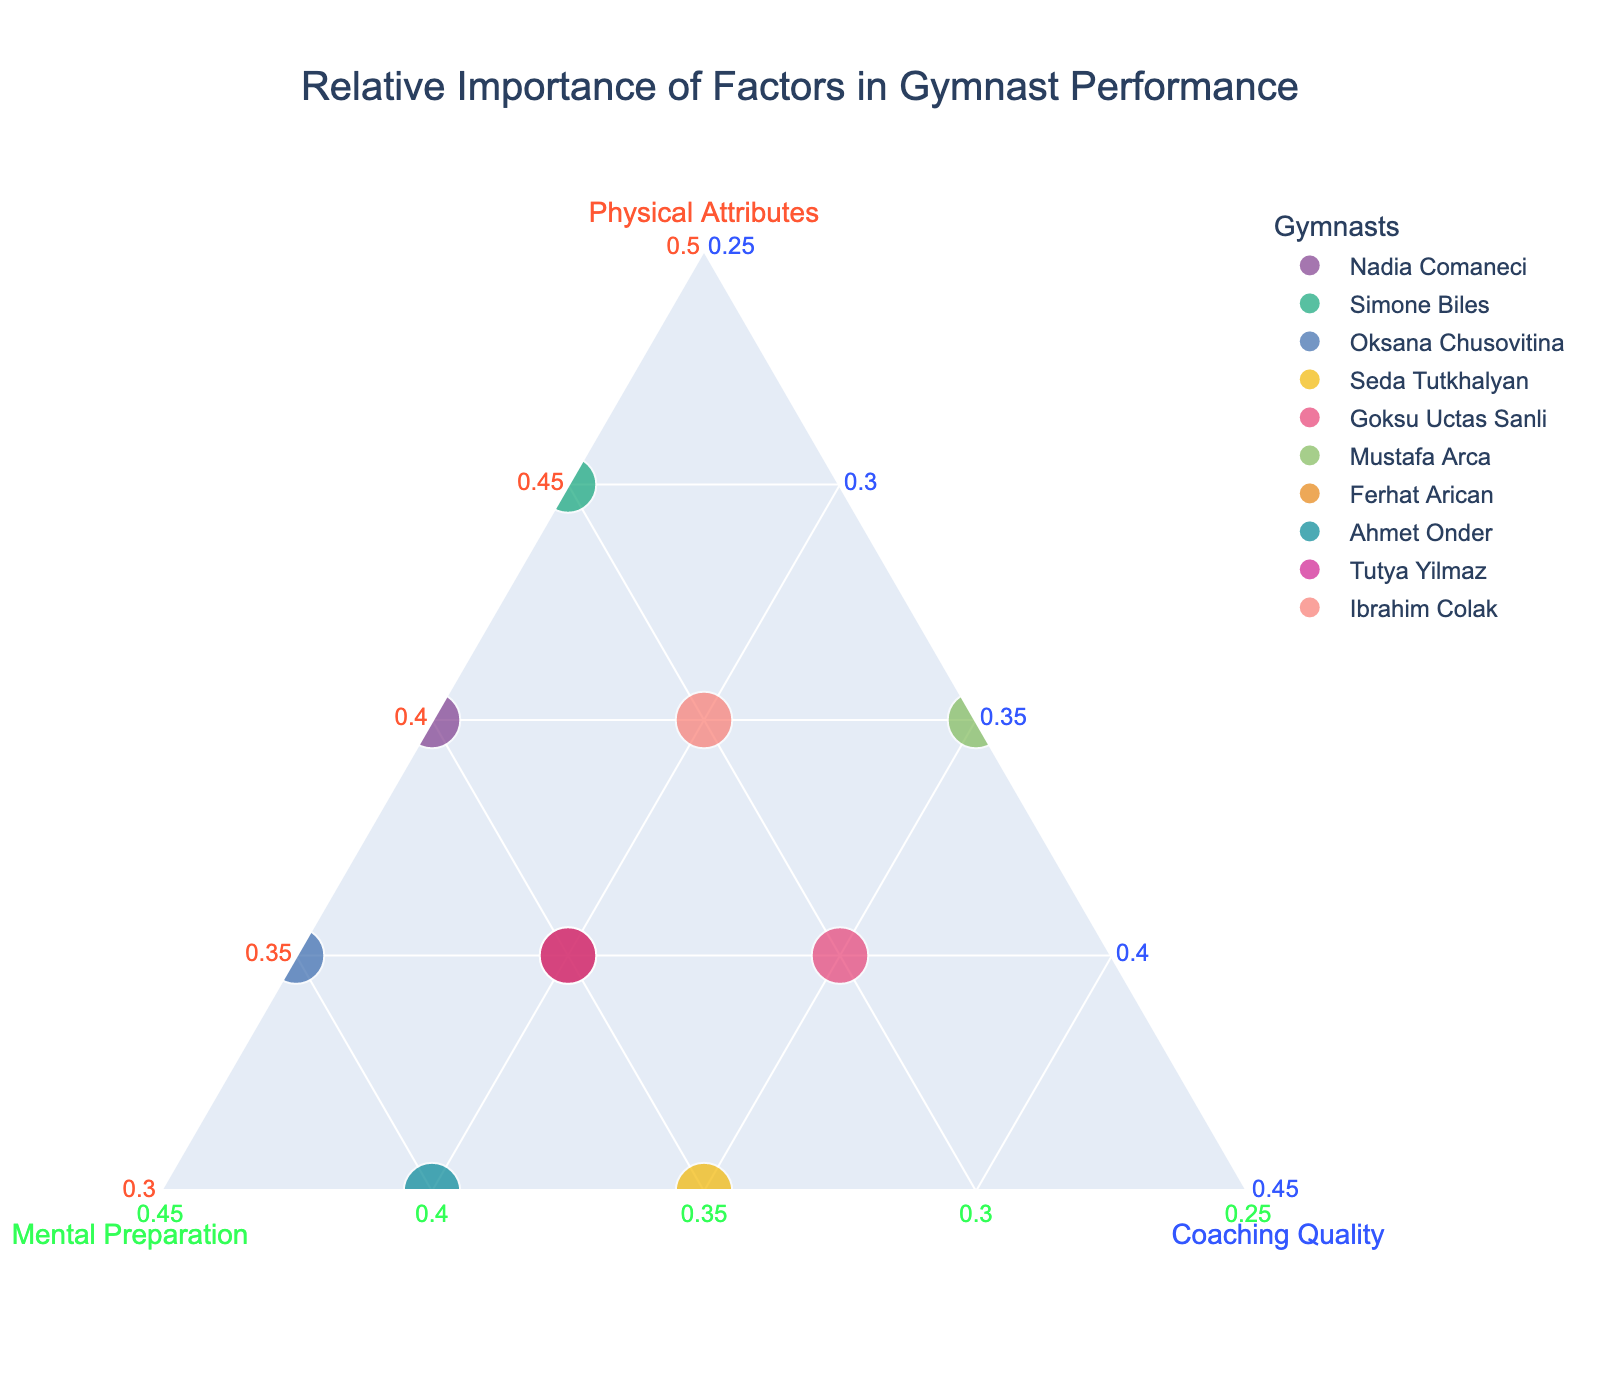Which gymnast relies the most on physical attributes? To determine this, we look for the highest value on the axis labeled "Physical Attributes." Simone Biles has the highest value at 0.45.
Answer: Simone Biles How many gymnasts have coaching quality as their most influential factor? We need to count the gymnasts whose highest value is for "Coaching Quality." Leta analyze the data: only Seda Tutkhalyan and Goksu Uctas Sanli are positioned with their highest value in "Coaching Quality" with 0.35.
Answer: 2 What is the combined influence of physical attributes and mental preparation for Oksana Chusovitina? We sum the values for "Physical Attributes" (0.35) and "Mental Preparation" (0.40): 0.35 + 0.40 = 0.75.
Answer: 0.75 Which two gymnasts have the same compositional balance between mental preparation and coaching quality? We need to identify gymnasts with equal values for "Mental Preparation" and "Coaching Quality." Nadia Comaneci and Simone Biles both have 0.35 and 0.25 respectively.
Answer: Nadia Comaneci and Simone Biles Who is the gymnast with the least emphasis on mental preparation? Look for the lowest value on the axis labeled "Mental Preparation." Mustafa Arca has the lowest value at 0.25.
Answer: Mustafa Arca Compare the importance of coaching quality between Ferhat Arican and Tutya Yilmaz. Ferhat Arican has a coaching quality value of 0.30, and Tutya Yilmaz has an identical value of 0.30. Thus, both gymnasts have equal importance placed on coaching quality.
Answer: Equal What is the average value of coaching quality across all gymnasts? To find the average, sum all coaching quality values and divide by the number of gymnasts: (0.25+0.25+0.25+0.35+0.35+0.35+0.30+0.30+0.30+0.30) / 10 = 3.00/10 = 0.30.
Answer: 0.30 Which gymnast prioritizes mental preparation and has the highest value for it? Look for the highest value in "Mental Preparation." Ahmet Onder, with a value of 0.40, prioritizes mental preparation the most.
Answer: Ahmet Onder Do any gymnasts have equal weights for mental preparation and physical attributes? Check for gymnasts with equal values for "Mental Preparation" and "Physical Attributes." Ferhat Arican and Tutya Yilmaz both have 0.35 for both factors.
Answer: Ferhat Arican and Tutya Yilmaz 